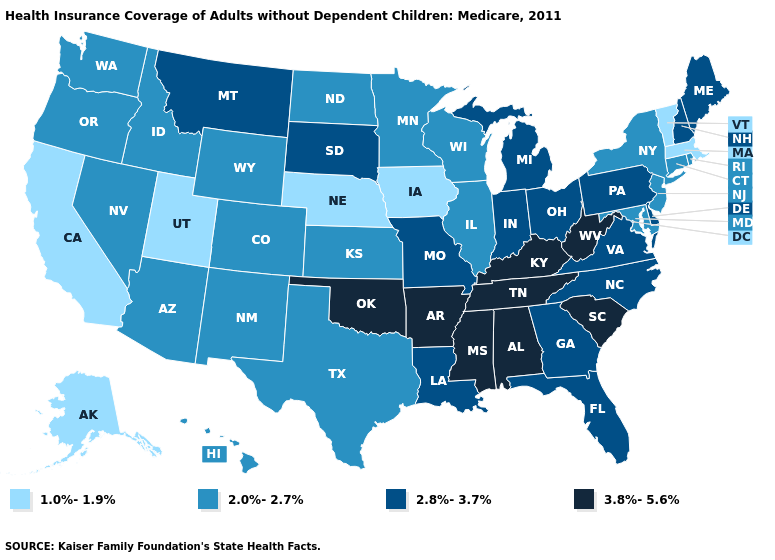Does North Carolina have the lowest value in the USA?
Short answer required. No. Name the states that have a value in the range 2.0%-2.7%?
Short answer required. Arizona, Colorado, Connecticut, Hawaii, Idaho, Illinois, Kansas, Maryland, Minnesota, Nevada, New Jersey, New Mexico, New York, North Dakota, Oregon, Rhode Island, Texas, Washington, Wisconsin, Wyoming. Does Colorado have a higher value than Illinois?
Be succinct. No. What is the value of Georgia?
Be succinct. 2.8%-3.7%. Name the states that have a value in the range 1.0%-1.9%?
Short answer required. Alaska, California, Iowa, Massachusetts, Nebraska, Utah, Vermont. Which states hav the highest value in the South?
Concise answer only. Alabama, Arkansas, Kentucky, Mississippi, Oklahoma, South Carolina, Tennessee, West Virginia. What is the lowest value in the USA?
Short answer required. 1.0%-1.9%. Does Arizona have the same value as California?
Concise answer only. No. Does Pennsylvania have the highest value in the Northeast?
Quick response, please. Yes. What is the value of Nevada?
Give a very brief answer. 2.0%-2.7%. What is the value of Georgia?
Give a very brief answer. 2.8%-3.7%. How many symbols are there in the legend?
Be succinct. 4. What is the highest value in states that border South Carolina?
Answer briefly. 2.8%-3.7%. What is the value of Idaho?
Write a very short answer. 2.0%-2.7%. Which states hav the highest value in the West?
Give a very brief answer. Montana. 